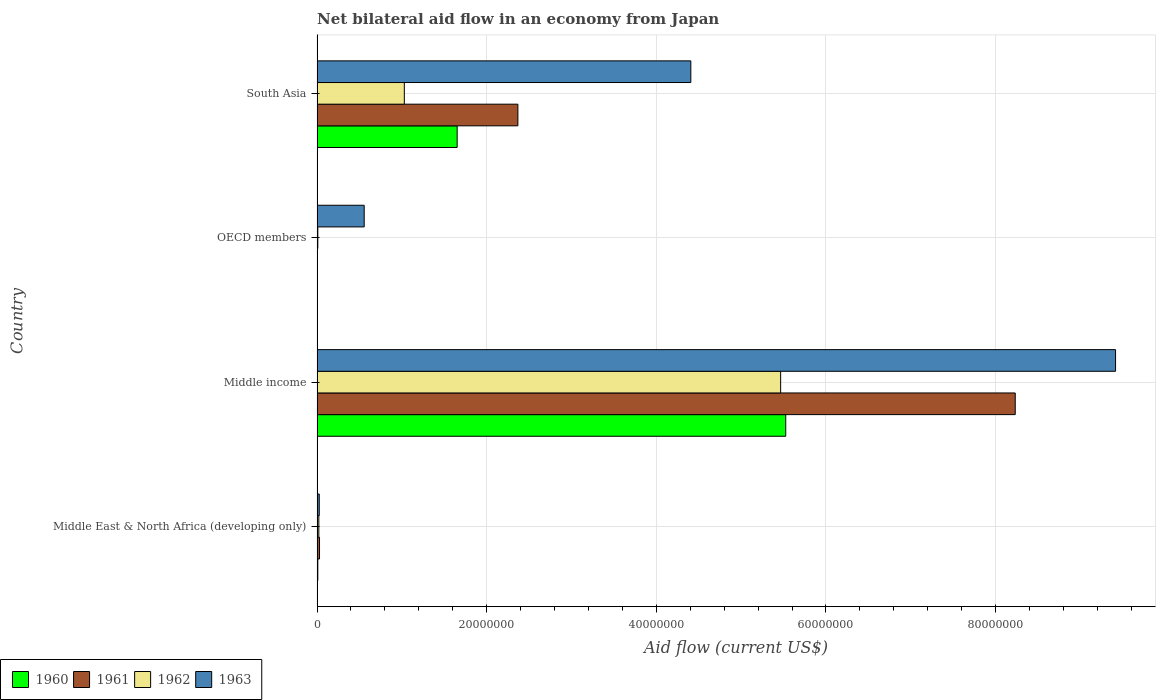How many bars are there on the 4th tick from the top?
Provide a succinct answer. 4. What is the label of the 4th group of bars from the top?
Your answer should be very brief. Middle East & North Africa (developing only). What is the net bilateral aid flow in 1960 in OECD members?
Keep it short and to the point. 3.00e+04. Across all countries, what is the maximum net bilateral aid flow in 1962?
Offer a terse response. 5.47e+07. In which country was the net bilateral aid flow in 1962 maximum?
Ensure brevity in your answer.  Middle income. What is the total net bilateral aid flow in 1960 in the graph?
Ensure brevity in your answer.  7.19e+07. What is the difference between the net bilateral aid flow in 1961 in Middle East & North Africa (developing only) and that in South Asia?
Give a very brief answer. -2.34e+07. What is the difference between the net bilateral aid flow in 1962 in South Asia and the net bilateral aid flow in 1963 in Middle income?
Offer a terse response. -8.39e+07. What is the average net bilateral aid flow in 1963 per country?
Provide a short and direct response. 3.60e+07. What is the difference between the net bilateral aid flow in 1960 and net bilateral aid flow in 1961 in OECD members?
Offer a very short reply. -2.00e+04. In how many countries, is the net bilateral aid flow in 1963 greater than 12000000 US$?
Your answer should be very brief. 2. What is the ratio of the net bilateral aid flow in 1960 in Middle East & North Africa (developing only) to that in Middle income?
Ensure brevity in your answer.  0. What is the difference between the highest and the second highest net bilateral aid flow in 1962?
Offer a terse response. 4.44e+07. What is the difference between the highest and the lowest net bilateral aid flow in 1961?
Ensure brevity in your answer.  8.23e+07. Is the sum of the net bilateral aid flow in 1960 in OECD members and South Asia greater than the maximum net bilateral aid flow in 1962 across all countries?
Your answer should be compact. No. Is it the case that in every country, the sum of the net bilateral aid flow in 1963 and net bilateral aid flow in 1962 is greater than the sum of net bilateral aid flow in 1961 and net bilateral aid flow in 1960?
Your answer should be compact. No. What does the 1st bar from the top in South Asia represents?
Keep it short and to the point. 1963. Does the graph contain grids?
Your response must be concise. Yes. Where does the legend appear in the graph?
Your response must be concise. Bottom left. How many legend labels are there?
Offer a terse response. 4. What is the title of the graph?
Your answer should be very brief. Net bilateral aid flow in an economy from Japan. What is the label or title of the X-axis?
Your answer should be compact. Aid flow (current US$). What is the Aid flow (current US$) of 1961 in Middle East & North Africa (developing only)?
Your answer should be compact. 2.90e+05. What is the Aid flow (current US$) of 1962 in Middle East & North Africa (developing only)?
Offer a very short reply. 2.10e+05. What is the Aid flow (current US$) in 1960 in Middle income?
Your answer should be compact. 5.53e+07. What is the Aid flow (current US$) in 1961 in Middle income?
Give a very brief answer. 8.23e+07. What is the Aid flow (current US$) of 1962 in Middle income?
Your answer should be compact. 5.47e+07. What is the Aid flow (current US$) in 1963 in Middle income?
Make the answer very short. 9.42e+07. What is the Aid flow (current US$) of 1960 in OECD members?
Ensure brevity in your answer.  3.00e+04. What is the Aid flow (current US$) of 1961 in OECD members?
Provide a succinct answer. 5.00e+04. What is the Aid flow (current US$) of 1962 in OECD members?
Your answer should be compact. 9.00e+04. What is the Aid flow (current US$) in 1963 in OECD members?
Offer a very short reply. 5.56e+06. What is the Aid flow (current US$) in 1960 in South Asia?
Ensure brevity in your answer.  1.65e+07. What is the Aid flow (current US$) in 1961 in South Asia?
Provide a succinct answer. 2.37e+07. What is the Aid flow (current US$) of 1962 in South Asia?
Your answer should be very brief. 1.03e+07. What is the Aid flow (current US$) of 1963 in South Asia?
Provide a succinct answer. 4.41e+07. Across all countries, what is the maximum Aid flow (current US$) in 1960?
Your answer should be compact. 5.53e+07. Across all countries, what is the maximum Aid flow (current US$) in 1961?
Offer a terse response. 8.23e+07. Across all countries, what is the maximum Aid flow (current US$) of 1962?
Give a very brief answer. 5.47e+07. Across all countries, what is the maximum Aid flow (current US$) in 1963?
Your answer should be compact. 9.42e+07. Across all countries, what is the minimum Aid flow (current US$) in 1960?
Offer a very short reply. 3.00e+04. Across all countries, what is the minimum Aid flow (current US$) in 1961?
Your answer should be very brief. 5.00e+04. What is the total Aid flow (current US$) in 1960 in the graph?
Your answer should be very brief. 7.19e+07. What is the total Aid flow (current US$) of 1961 in the graph?
Keep it short and to the point. 1.06e+08. What is the total Aid flow (current US$) in 1962 in the graph?
Keep it short and to the point. 6.52e+07. What is the total Aid flow (current US$) in 1963 in the graph?
Provide a short and direct response. 1.44e+08. What is the difference between the Aid flow (current US$) of 1960 in Middle East & North Africa (developing only) and that in Middle income?
Give a very brief answer. -5.52e+07. What is the difference between the Aid flow (current US$) in 1961 in Middle East & North Africa (developing only) and that in Middle income?
Give a very brief answer. -8.20e+07. What is the difference between the Aid flow (current US$) in 1962 in Middle East & North Africa (developing only) and that in Middle income?
Your response must be concise. -5.44e+07. What is the difference between the Aid flow (current US$) in 1963 in Middle East & North Africa (developing only) and that in Middle income?
Make the answer very short. -9.39e+07. What is the difference between the Aid flow (current US$) in 1960 in Middle East & North Africa (developing only) and that in OECD members?
Your answer should be compact. 6.00e+04. What is the difference between the Aid flow (current US$) in 1963 in Middle East & North Africa (developing only) and that in OECD members?
Make the answer very short. -5.30e+06. What is the difference between the Aid flow (current US$) of 1960 in Middle East & North Africa (developing only) and that in South Asia?
Provide a succinct answer. -1.64e+07. What is the difference between the Aid flow (current US$) of 1961 in Middle East & North Africa (developing only) and that in South Asia?
Give a very brief answer. -2.34e+07. What is the difference between the Aid flow (current US$) of 1962 in Middle East & North Africa (developing only) and that in South Asia?
Give a very brief answer. -1.01e+07. What is the difference between the Aid flow (current US$) in 1963 in Middle East & North Africa (developing only) and that in South Asia?
Provide a short and direct response. -4.38e+07. What is the difference between the Aid flow (current US$) of 1960 in Middle income and that in OECD members?
Provide a succinct answer. 5.52e+07. What is the difference between the Aid flow (current US$) in 1961 in Middle income and that in OECD members?
Offer a terse response. 8.23e+07. What is the difference between the Aid flow (current US$) in 1962 in Middle income and that in OECD members?
Make the answer very short. 5.46e+07. What is the difference between the Aid flow (current US$) of 1963 in Middle income and that in OECD members?
Provide a succinct answer. 8.86e+07. What is the difference between the Aid flow (current US$) in 1960 in Middle income and that in South Asia?
Keep it short and to the point. 3.87e+07. What is the difference between the Aid flow (current US$) in 1961 in Middle income and that in South Asia?
Make the answer very short. 5.86e+07. What is the difference between the Aid flow (current US$) in 1962 in Middle income and that in South Asia?
Make the answer very short. 4.44e+07. What is the difference between the Aid flow (current US$) in 1963 in Middle income and that in South Asia?
Offer a terse response. 5.01e+07. What is the difference between the Aid flow (current US$) in 1960 in OECD members and that in South Asia?
Your answer should be compact. -1.65e+07. What is the difference between the Aid flow (current US$) of 1961 in OECD members and that in South Asia?
Offer a terse response. -2.36e+07. What is the difference between the Aid flow (current US$) of 1962 in OECD members and that in South Asia?
Offer a terse response. -1.02e+07. What is the difference between the Aid flow (current US$) of 1963 in OECD members and that in South Asia?
Your response must be concise. -3.85e+07. What is the difference between the Aid flow (current US$) of 1960 in Middle East & North Africa (developing only) and the Aid flow (current US$) of 1961 in Middle income?
Keep it short and to the point. -8.22e+07. What is the difference between the Aid flow (current US$) of 1960 in Middle East & North Africa (developing only) and the Aid flow (current US$) of 1962 in Middle income?
Your answer should be very brief. -5.46e+07. What is the difference between the Aid flow (current US$) of 1960 in Middle East & North Africa (developing only) and the Aid flow (current US$) of 1963 in Middle income?
Ensure brevity in your answer.  -9.41e+07. What is the difference between the Aid flow (current US$) of 1961 in Middle East & North Africa (developing only) and the Aid flow (current US$) of 1962 in Middle income?
Provide a succinct answer. -5.44e+07. What is the difference between the Aid flow (current US$) in 1961 in Middle East & North Africa (developing only) and the Aid flow (current US$) in 1963 in Middle income?
Provide a succinct answer. -9.39e+07. What is the difference between the Aid flow (current US$) in 1962 in Middle East & North Africa (developing only) and the Aid flow (current US$) in 1963 in Middle income?
Ensure brevity in your answer.  -9.39e+07. What is the difference between the Aid flow (current US$) in 1960 in Middle East & North Africa (developing only) and the Aid flow (current US$) in 1961 in OECD members?
Make the answer very short. 4.00e+04. What is the difference between the Aid flow (current US$) of 1960 in Middle East & North Africa (developing only) and the Aid flow (current US$) of 1963 in OECD members?
Your answer should be very brief. -5.47e+06. What is the difference between the Aid flow (current US$) in 1961 in Middle East & North Africa (developing only) and the Aid flow (current US$) in 1963 in OECD members?
Offer a very short reply. -5.27e+06. What is the difference between the Aid flow (current US$) in 1962 in Middle East & North Africa (developing only) and the Aid flow (current US$) in 1963 in OECD members?
Offer a very short reply. -5.35e+06. What is the difference between the Aid flow (current US$) of 1960 in Middle East & North Africa (developing only) and the Aid flow (current US$) of 1961 in South Asia?
Offer a terse response. -2.36e+07. What is the difference between the Aid flow (current US$) of 1960 in Middle East & North Africa (developing only) and the Aid flow (current US$) of 1962 in South Asia?
Offer a terse response. -1.02e+07. What is the difference between the Aid flow (current US$) in 1960 in Middle East & North Africa (developing only) and the Aid flow (current US$) in 1963 in South Asia?
Your answer should be very brief. -4.40e+07. What is the difference between the Aid flow (current US$) in 1961 in Middle East & North Africa (developing only) and the Aid flow (current US$) in 1962 in South Asia?
Your answer should be compact. -1.00e+07. What is the difference between the Aid flow (current US$) of 1961 in Middle East & North Africa (developing only) and the Aid flow (current US$) of 1963 in South Asia?
Provide a succinct answer. -4.38e+07. What is the difference between the Aid flow (current US$) of 1962 in Middle East & North Africa (developing only) and the Aid flow (current US$) of 1963 in South Asia?
Keep it short and to the point. -4.39e+07. What is the difference between the Aid flow (current US$) of 1960 in Middle income and the Aid flow (current US$) of 1961 in OECD members?
Your answer should be very brief. 5.52e+07. What is the difference between the Aid flow (current US$) of 1960 in Middle income and the Aid flow (current US$) of 1962 in OECD members?
Your answer should be compact. 5.52e+07. What is the difference between the Aid flow (current US$) of 1960 in Middle income and the Aid flow (current US$) of 1963 in OECD members?
Your response must be concise. 4.97e+07. What is the difference between the Aid flow (current US$) in 1961 in Middle income and the Aid flow (current US$) in 1962 in OECD members?
Provide a short and direct response. 8.22e+07. What is the difference between the Aid flow (current US$) of 1961 in Middle income and the Aid flow (current US$) of 1963 in OECD members?
Offer a very short reply. 7.68e+07. What is the difference between the Aid flow (current US$) of 1962 in Middle income and the Aid flow (current US$) of 1963 in OECD members?
Make the answer very short. 4.91e+07. What is the difference between the Aid flow (current US$) in 1960 in Middle income and the Aid flow (current US$) in 1961 in South Asia?
Offer a terse response. 3.16e+07. What is the difference between the Aid flow (current US$) of 1960 in Middle income and the Aid flow (current US$) of 1962 in South Asia?
Provide a short and direct response. 4.50e+07. What is the difference between the Aid flow (current US$) of 1960 in Middle income and the Aid flow (current US$) of 1963 in South Asia?
Provide a succinct answer. 1.12e+07. What is the difference between the Aid flow (current US$) of 1961 in Middle income and the Aid flow (current US$) of 1962 in South Asia?
Your answer should be compact. 7.20e+07. What is the difference between the Aid flow (current US$) in 1961 in Middle income and the Aid flow (current US$) in 1963 in South Asia?
Provide a succinct answer. 3.82e+07. What is the difference between the Aid flow (current US$) in 1962 in Middle income and the Aid flow (current US$) in 1963 in South Asia?
Provide a short and direct response. 1.06e+07. What is the difference between the Aid flow (current US$) of 1960 in OECD members and the Aid flow (current US$) of 1961 in South Asia?
Give a very brief answer. -2.36e+07. What is the difference between the Aid flow (current US$) of 1960 in OECD members and the Aid flow (current US$) of 1962 in South Asia?
Your response must be concise. -1.03e+07. What is the difference between the Aid flow (current US$) in 1960 in OECD members and the Aid flow (current US$) in 1963 in South Asia?
Ensure brevity in your answer.  -4.40e+07. What is the difference between the Aid flow (current US$) in 1961 in OECD members and the Aid flow (current US$) in 1962 in South Asia?
Offer a terse response. -1.02e+07. What is the difference between the Aid flow (current US$) in 1961 in OECD members and the Aid flow (current US$) in 1963 in South Asia?
Keep it short and to the point. -4.40e+07. What is the difference between the Aid flow (current US$) of 1962 in OECD members and the Aid flow (current US$) of 1963 in South Asia?
Provide a succinct answer. -4.40e+07. What is the average Aid flow (current US$) in 1960 per country?
Your response must be concise. 1.80e+07. What is the average Aid flow (current US$) of 1961 per country?
Your answer should be compact. 2.66e+07. What is the average Aid flow (current US$) in 1962 per country?
Your response must be concise. 1.63e+07. What is the average Aid flow (current US$) in 1963 per country?
Give a very brief answer. 3.60e+07. What is the difference between the Aid flow (current US$) in 1960 and Aid flow (current US$) in 1961 in Middle East & North Africa (developing only)?
Offer a terse response. -2.00e+05. What is the difference between the Aid flow (current US$) in 1960 and Aid flow (current US$) in 1962 in Middle East & North Africa (developing only)?
Offer a very short reply. -1.20e+05. What is the difference between the Aid flow (current US$) in 1960 and Aid flow (current US$) in 1963 in Middle East & North Africa (developing only)?
Offer a very short reply. -1.70e+05. What is the difference between the Aid flow (current US$) of 1962 and Aid flow (current US$) of 1963 in Middle East & North Africa (developing only)?
Keep it short and to the point. -5.00e+04. What is the difference between the Aid flow (current US$) in 1960 and Aid flow (current US$) in 1961 in Middle income?
Offer a terse response. -2.71e+07. What is the difference between the Aid flow (current US$) in 1960 and Aid flow (current US$) in 1963 in Middle income?
Make the answer very short. -3.89e+07. What is the difference between the Aid flow (current US$) in 1961 and Aid flow (current US$) in 1962 in Middle income?
Keep it short and to the point. 2.77e+07. What is the difference between the Aid flow (current US$) in 1961 and Aid flow (current US$) in 1963 in Middle income?
Offer a very short reply. -1.18e+07. What is the difference between the Aid flow (current US$) in 1962 and Aid flow (current US$) in 1963 in Middle income?
Ensure brevity in your answer.  -3.95e+07. What is the difference between the Aid flow (current US$) in 1960 and Aid flow (current US$) in 1961 in OECD members?
Your answer should be very brief. -2.00e+04. What is the difference between the Aid flow (current US$) of 1960 and Aid flow (current US$) of 1963 in OECD members?
Offer a terse response. -5.53e+06. What is the difference between the Aid flow (current US$) in 1961 and Aid flow (current US$) in 1962 in OECD members?
Offer a terse response. -4.00e+04. What is the difference between the Aid flow (current US$) of 1961 and Aid flow (current US$) of 1963 in OECD members?
Offer a very short reply. -5.51e+06. What is the difference between the Aid flow (current US$) of 1962 and Aid flow (current US$) of 1963 in OECD members?
Provide a succinct answer. -5.47e+06. What is the difference between the Aid flow (current US$) of 1960 and Aid flow (current US$) of 1961 in South Asia?
Make the answer very short. -7.16e+06. What is the difference between the Aid flow (current US$) of 1960 and Aid flow (current US$) of 1962 in South Asia?
Offer a very short reply. 6.23e+06. What is the difference between the Aid flow (current US$) in 1960 and Aid flow (current US$) in 1963 in South Asia?
Your response must be concise. -2.76e+07. What is the difference between the Aid flow (current US$) of 1961 and Aid flow (current US$) of 1962 in South Asia?
Keep it short and to the point. 1.34e+07. What is the difference between the Aid flow (current US$) of 1961 and Aid flow (current US$) of 1963 in South Asia?
Keep it short and to the point. -2.04e+07. What is the difference between the Aid flow (current US$) of 1962 and Aid flow (current US$) of 1963 in South Asia?
Your answer should be compact. -3.38e+07. What is the ratio of the Aid flow (current US$) in 1960 in Middle East & North Africa (developing only) to that in Middle income?
Provide a short and direct response. 0. What is the ratio of the Aid flow (current US$) in 1961 in Middle East & North Africa (developing only) to that in Middle income?
Your answer should be compact. 0. What is the ratio of the Aid flow (current US$) of 1962 in Middle East & North Africa (developing only) to that in Middle income?
Give a very brief answer. 0. What is the ratio of the Aid flow (current US$) in 1963 in Middle East & North Africa (developing only) to that in Middle income?
Offer a terse response. 0. What is the ratio of the Aid flow (current US$) in 1961 in Middle East & North Africa (developing only) to that in OECD members?
Your answer should be very brief. 5.8. What is the ratio of the Aid flow (current US$) of 1962 in Middle East & North Africa (developing only) to that in OECD members?
Provide a succinct answer. 2.33. What is the ratio of the Aid flow (current US$) of 1963 in Middle East & North Africa (developing only) to that in OECD members?
Make the answer very short. 0.05. What is the ratio of the Aid flow (current US$) in 1960 in Middle East & North Africa (developing only) to that in South Asia?
Your answer should be compact. 0.01. What is the ratio of the Aid flow (current US$) in 1961 in Middle East & North Africa (developing only) to that in South Asia?
Give a very brief answer. 0.01. What is the ratio of the Aid flow (current US$) of 1962 in Middle East & North Africa (developing only) to that in South Asia?
Your answer should be compact. 0.02. What is the ratio of the Aid flow (current US$) of 1963 in Middle East & North Africa (developing only) to that in South Asia?
Give a very brief answer. 0.01. What is the ratio of the Aid flow (current US$) in 1960 in Middle income to that in OECD members?
Provide a short and direct response. 1842. What is the ratio of the Aid flow (current US$) of 1961 in Middle income to that in OECD members?
Ensure brevity in your answer.  1646.4. What is the ratio of the Aid flow (current US$) in 1962 in Middle income to that in OECD members?
Keep it short and to the point. 607.33. What is the ratio of the Aid flow (current US$) in 1963 in Middle income to that in OECD members?
Your response must be concise. 16.93. What is the ratio of the Aid flow (current US$) of 1960 in Middle income to that in South Asia?
Provide a succinct answer. 3.35. What is the ratio of the Aid flow (current US$) of 1961 in Middle income to that in South Asia?
Your answer should be compact. 3.48. What is the ratio of the Aid flow (current US$) in 1962 in Middle income to that in South Asia?
Keep it short and to the point. 5.31. What is the ratio of the Aid flow (current US$) in 1963 in Middle income to that in South Asia?
Ensure brevity in your answer.  2.14. What is the ratio of the Aid flow (current US$) in 1960 in OECD members to that in South Asia?
Offer a very short reply. 0. What is the ratio of the Aid flow (current US$) in 1961 in OECD members to that in South Asia?
Offer a very short reply. 0. What is the ratio of the Aid flow (current US$) in 1962 in OECD members to that in South Asia?
Your answer should be compact. 0.01. What is the ratio of the Aid flow (current US$) of 1963 in OECD members to that in South Asia?
Provide a succinct answer. 0.13. What is the difference between the highest and the second highest Aid flow (current US$) in 1960?
Keep it short and to the point. 3.87e+07. What is the difference between the highest and the second highest Aid flow (current US$) in 1961?
Ensure brevity in your answer.  5.86e+07. What is the difference between the highest and the second highest Aid flow (current US$) of 1962?
Your answer should be compact. 4.44e+07. What is the difference between the highest and the second highest Aid flow (current US$) in 1963?
Provide a short and direct response. 5.01e+07. What is the difference between the highest and the lowest Aid flow (current US$) of 1960?
Offer a terse response. 5.52e+07. What is the difference between the highest and the lowest Aid flow (current US$) of 1961?
Provide a short and direct response. 8.23e+07. What is the difference between the highest and the lowest Aid flow (current US$) of 1962?
Offer a terse response. 5.46e+07. What is the difference between the highest and the lowest Aid flow (current US$) of 1963?
Offer a very short reply. 9.39e+07. 